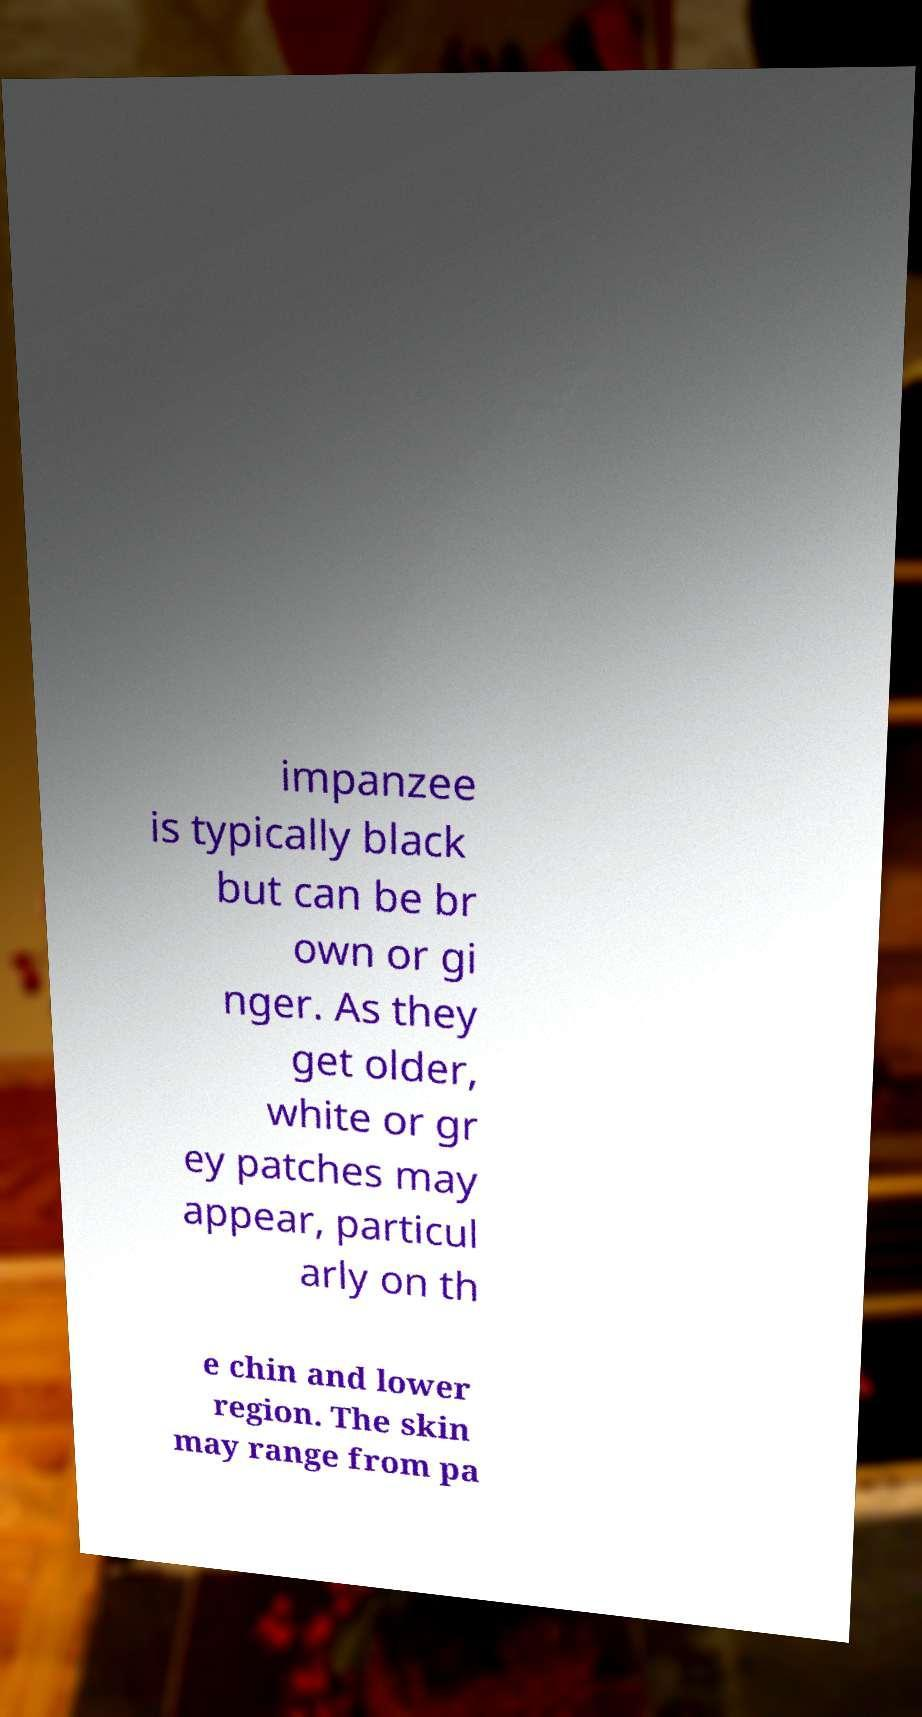I need the written content from this picture converted into text. Can you do that? impanzee is typically black but can be br own or gi nger. As they get older, white or gr ey patches may appear, particul arly on th e chin and lower region. The skin may range from pa 